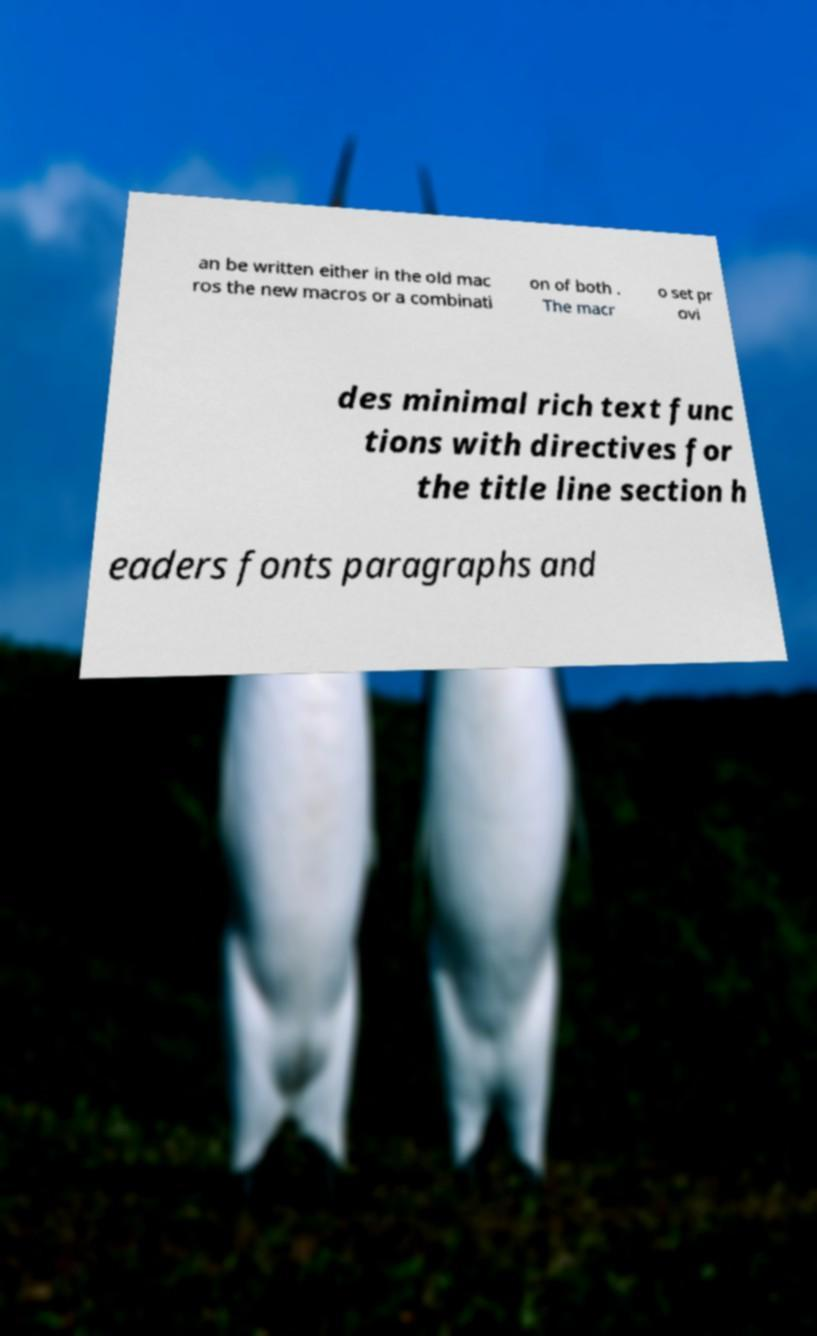Could you extract and type out the text from this image? an be written either in the old mac ros the new macros or a combinati on of both . The macr o set pr ovi des minimal rich text func tions with directives for the title line section h eaders fonts paragraphs and 